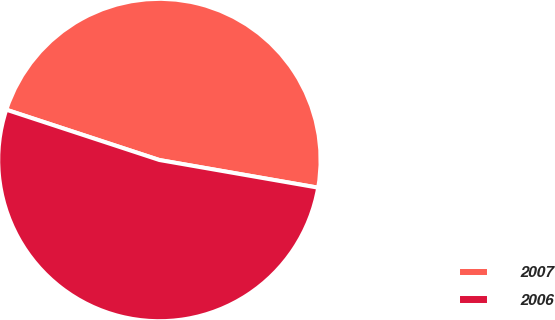Convert chart. <chart><loc_0><loc_0><loc_500><loc_500><pie_chart><fcel>2007<fcel>2006<nl><fcel>47.69%<fcel>52.31%<nl></chart> 